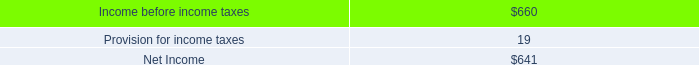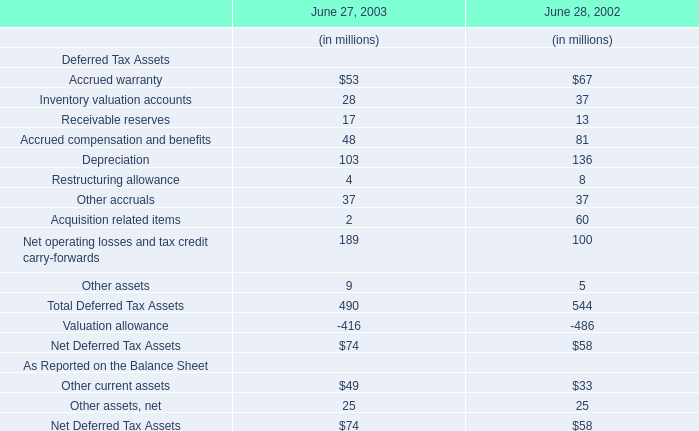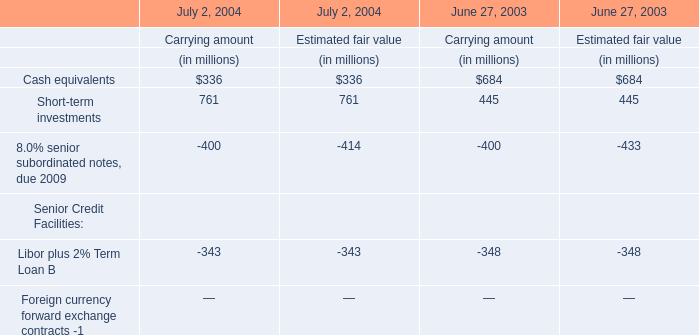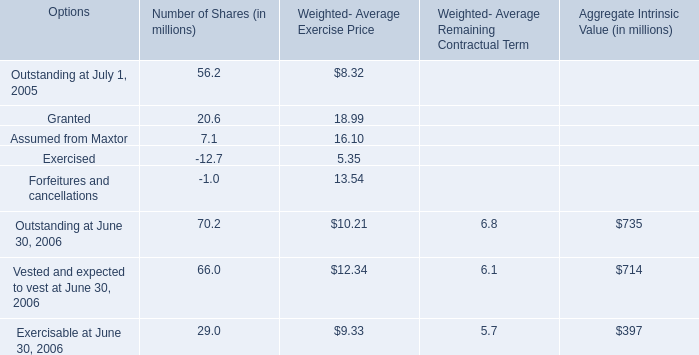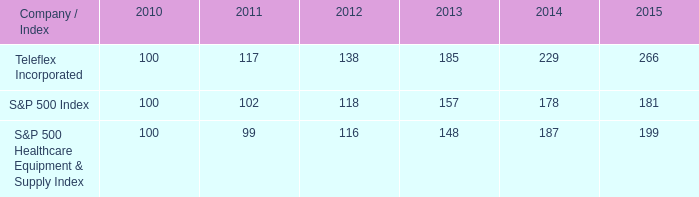What do all Number of Shares sum up, excluding those negative ones in 2005? (in million) 
Computations: ((56.2 + 20.6) + 7.1)
Answer: 83.9. 